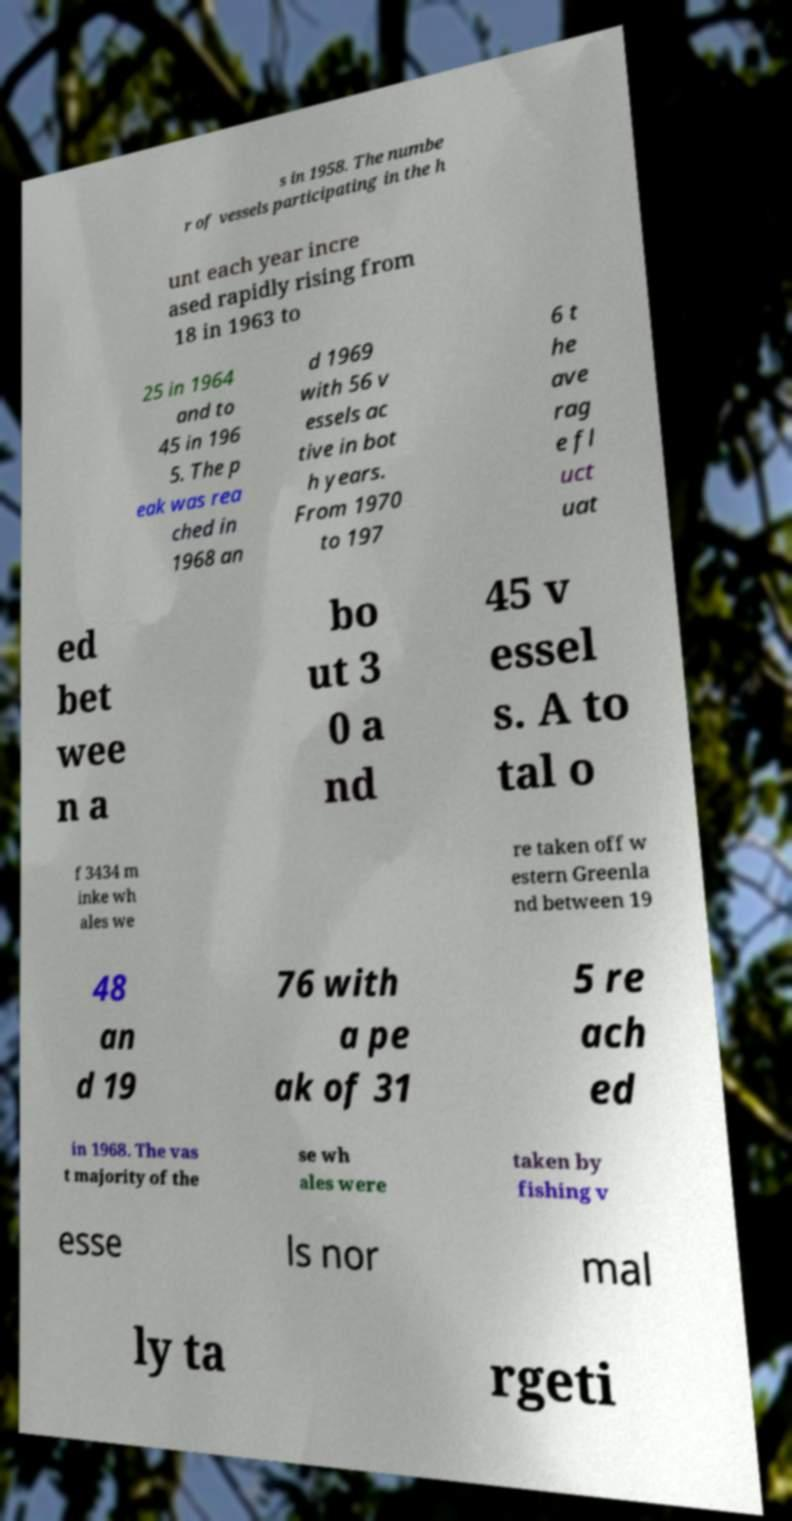Please read and relay the text visible in this image. What does it say? s in 1958. The numbe r of vessels participating in the h unt each year incre ased rapidly rising from 18 in 1963 to 25 in 1964 and to 45 in 196 5. The p eak was rea ched in 1968 an d 1969 with 56 v essels ac tive in bot h years. From 1970 to 197 6 t he ave rag e fl uct uat ed bet wee n a bo ut 3 0 a nd 45 v essel s. A to tal o f 3434 m inke wh ales we re taken off w estern Greenla nd between 19 48 an d 19 76 with a pe ak of 31 5 re ach ed in 1968. The vas t majority of the se wh ales were taken by fishing v esse ls nor mal ly ta rgeti 